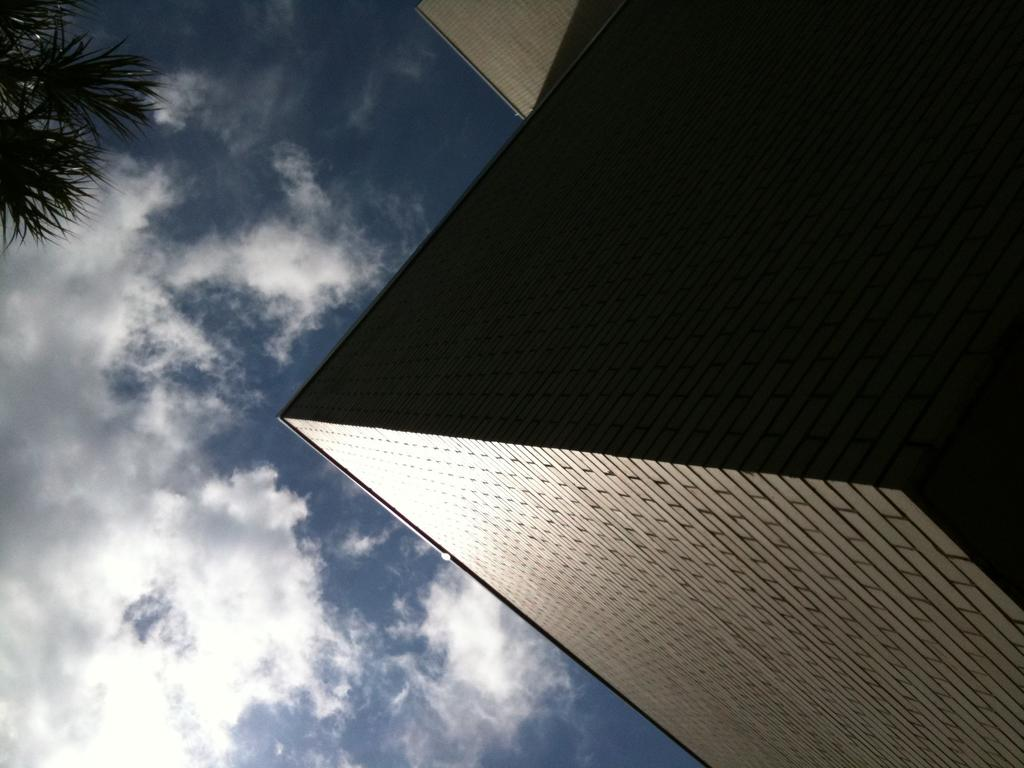What type of structure is present in the image? There is a building in the image. What is the color of the building? The building is brown in color. What can be seen to the left of the building? There is a tree to the left of the building. What is visible in the sky at the top of the image? There are clouds visible in the sky at the top of the image. Can you see a horse walking away from the building in the image? There is no horse present in the image, and therefore no such activity can be observed. 